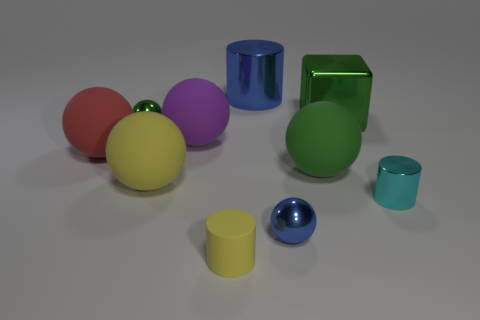Subtract all yellow cylinders. Subtract all purple blocks. How many cylinders are left? 2 Subtract all purple blocks. How many cyan cylinders are left? 1 Add 7 greens. How many tiny things exist? 0 Subtract all green shiny things. Subtract all metal blocks. How many objects are left? 7 Add 1 small cyan cylinders. How many small cyan cylinders are left? 2 Add 5 small matte things. How many small matte things exist? 6 Subtract all cyan cylinders. How many cylinders are left? 2 Subtract all green metallic balls. How many balls are left? 5 Subtract 0 brown cylinders. How many objects are left? 10 Subtract all balls. How many objects are left? 4 